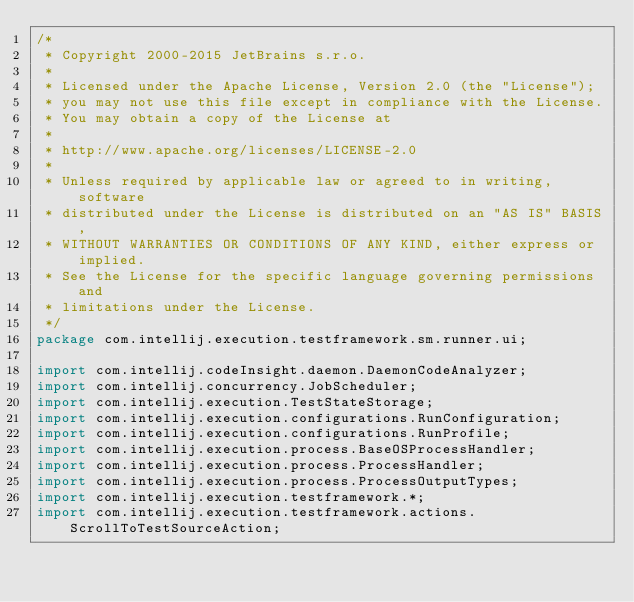Convert code to text. <code><loc_0><loc_0><loc_500><loc_500><_Java_>/*
 * Copyright 2000-2015 JetBrains s.r.o.
 *
 * Licensed under the Apache License, Version 2.0 (the "License");
 * you may not use this file except in compliance with the License.
 * You may obtain a copy of the License at
 *
 * http://www.apache.org/licenses/LICENSE-2.0
 *
 * Unless required by applicable law or agreed to in writing, software
 * distributed under the License is distributed on an "AS IS" BASIS,
 * WITHOUT WARRANTIES OR CONDITIONS OF ANY KIND, either express or implied.
 * See the License for the specific language governing permissions and
 * limitations under the License.
 */
package com.intellij.execution.testframework.sm.runner.ui;

import com.intellij.codeInsight.daemon.DaemonCodeAnalyzer;
import com.intellij.concurrency.JobScheduler;
import com.intellij.execution.TestStateStorage;
import com.intellij.execution.configurations.RunConfiguration;
import com.intellij.execution.configurations.RunProfile;
import com.intellij.execution.process.BaseOSProcessHandler;
import com.intellij.execution.process.ProcessHandler;
import com.intellij.execution.process.ProcessOutputTypes;
import com.intellij.execution.testframework.*;
import com.intellij.execution.testframework.actions.ScrollToTestSourceAction;</code> 